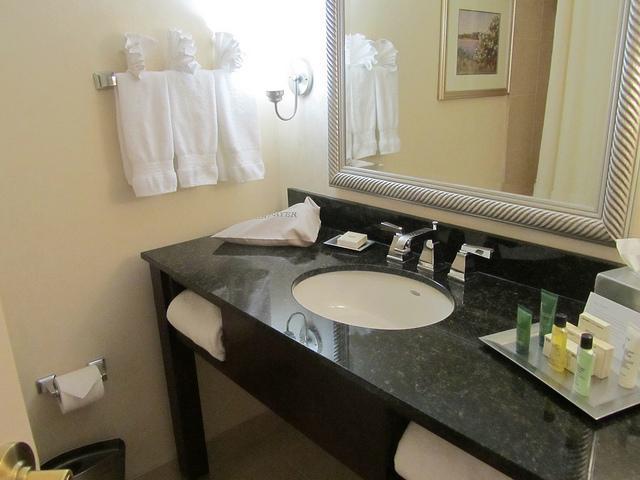How many towels are hanging on the wall?
Give a very brief answer. 3. How many rolls of toilet paper are there?
Give a very brief answer. 1. How many towels are there?
Give a very brief answer. 3. How many photos are show on the wall?
Give a very brief answer. 1. How many lights are there?
Give a very brief answer. 1. How many mirrors are pictured?
Give a very brief answer. 1. How many non-duplicate curtains are there?
Give a very brief answer. 1. How many mirrors can you see?
Give a very brief answer. 1. 